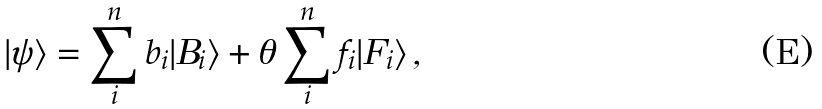Convert formula to latex. <formula><loc_0><loc_0><loc_500><loc_500>| \psi \rangle = \sum _ { i } ^ { n } b _ { i } | B _ { i } \rangle + \theta \sum _ { i } ^ { n } f _ { i } | F _ { i } \rangle \, ,</formula> 